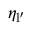<formula> <loc_0><loc_0><loc_500><loc_500>\eta _ { l ^ { \prime } }</formula> 